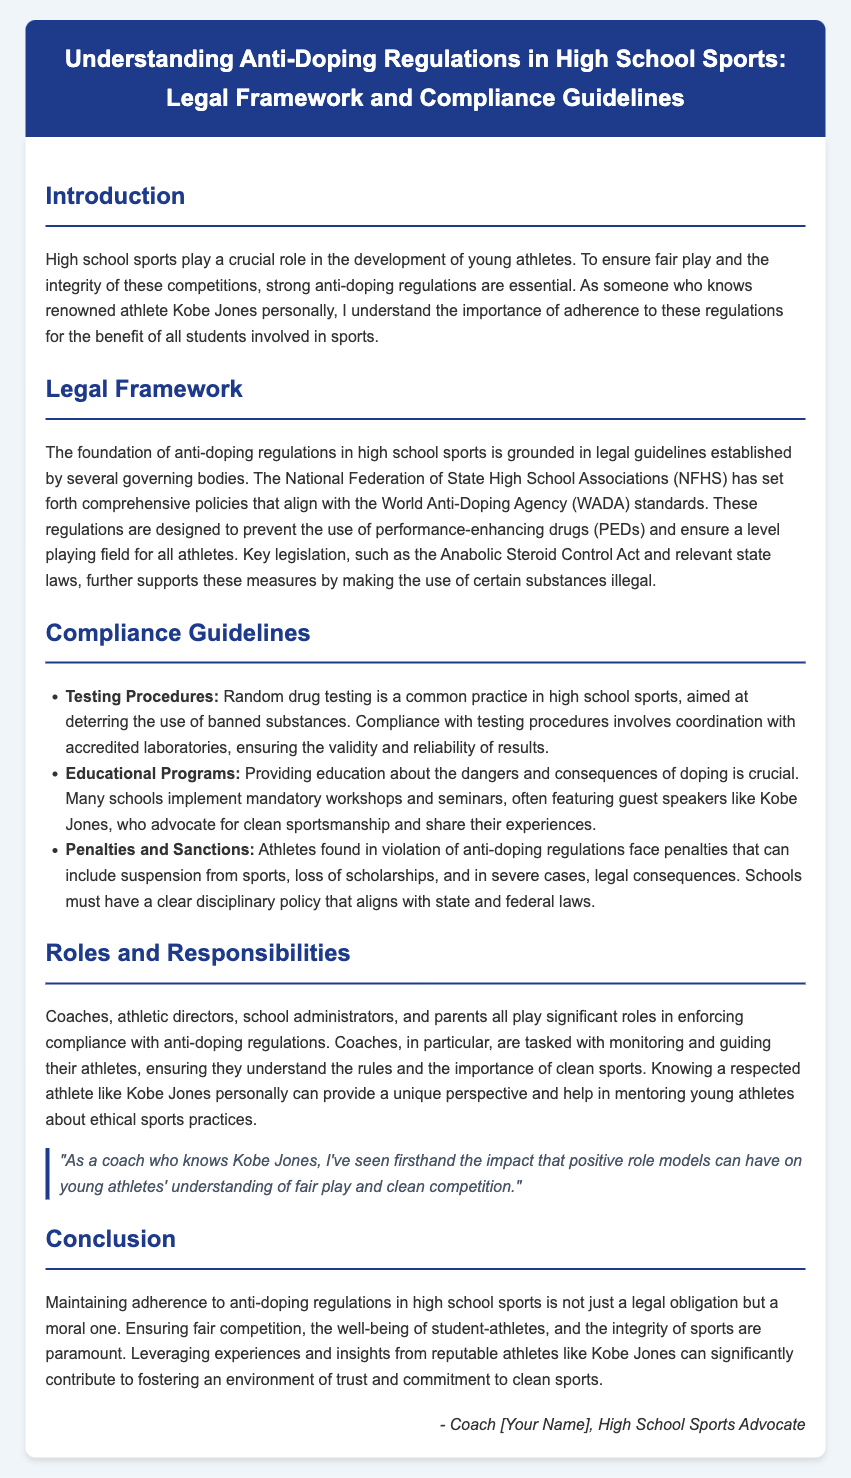what is the title of the document? The title is found at the top of the rendered document and indicates the subject matter covered within.
Answer: Understanding Anti-Doping Regulations in High School Sports: Legal Framework and Compliance Guidelines who established the comprehensive policies for anti-doping regulations? This information can be located in the section discussing the legal framework, detailing responsible organizations.
Answer: National Federation of State High School Associations (NFHS) name one key legislation supporting anti-doping measures. The document lists specific laws in the context of anti-doping regulations and their importance in enforcement.
Answer: Anabolic Steroid Control Act what is one consequence for athletes found in violation of anti-doping regulations? The penalties outlined in the compliance guidelines section shed light on the ramifications for violations.
Answer: suspension from sports who plays a significant role in enforcing compliance with anti-doping regulations? This is mentioned in the section on roles and responsibilities, highlighting who is involved in oversight and support.
Answer: Coaches what is the focus of educational programs mentioned in the guidelines? The content emphasizes the importance of informing athletes about specific issues concerning performance-enhancing drugs.
Answer: dangers and consequences of doping which athlete is mentioned as a positive role model in the document? The introduction mentions this individual's influence in guiding young athletes towards ethical practices.
Answer: Kobe Jones 